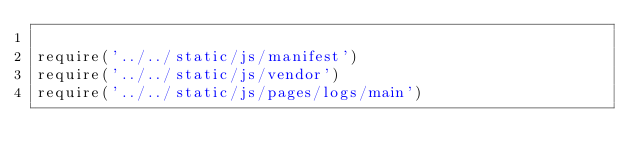<code> <loc_0><loc_0><loc_500><loc_500><_JavaScript_>
require('../../static/js/manifest')
require('../../static/js/vendor')
require('../../static/js/pages/logs/main')
</code> 